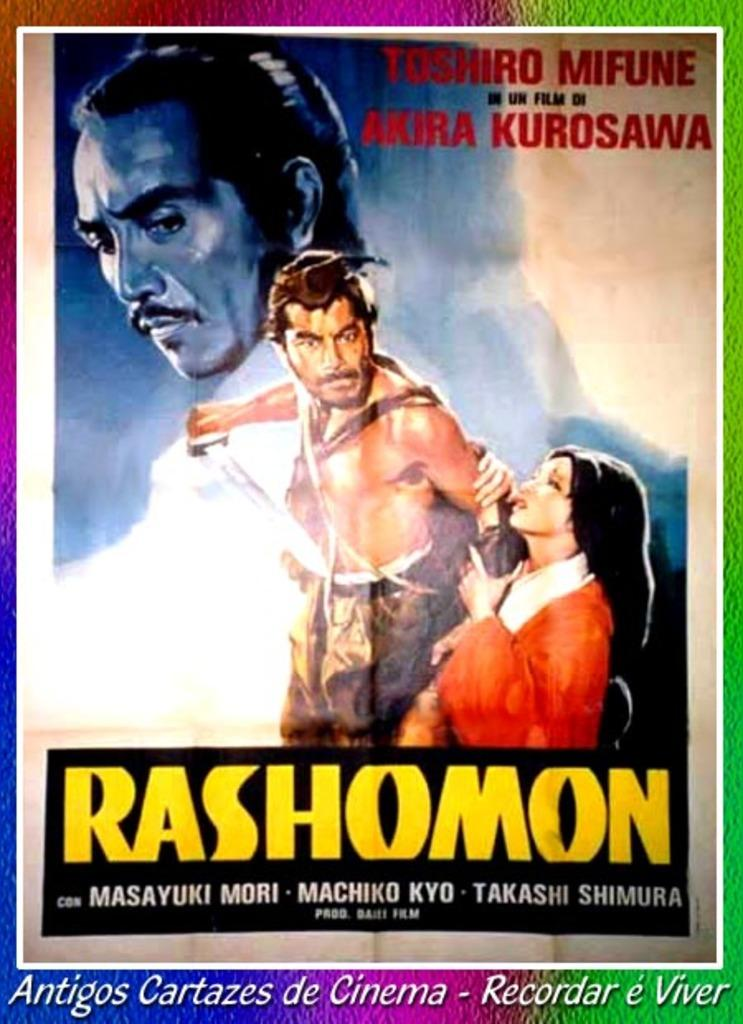<image>
Present a compact description of the photo's key features. An old movie poster for Rashomon hangs on a wall. 